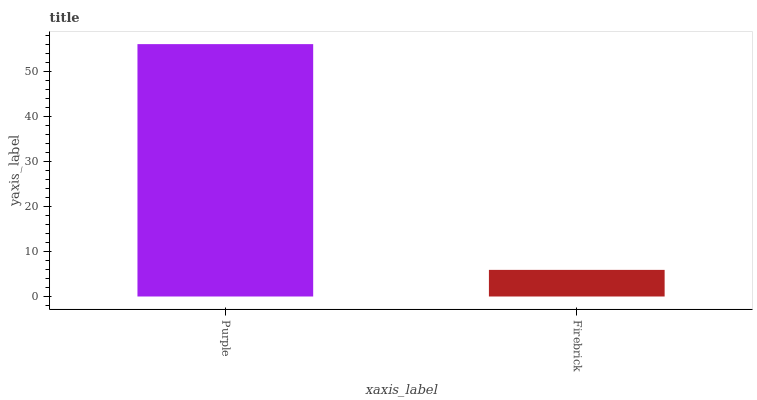Is Firebrick the minimum?
Answer yes or no. Yes. Is Purple the maximum?
Answer yes or no. Yes. Is Firebrick the maximum?
Answer yes or no. No. Is Purple greater than Firebrick?
Answer yes or no. Yes. Is Firebrick less than Purple?
Answer yes or no. Yes. Is Firebrick greater than Purple?
Answer yes or no. No. Is Purple less than Firebrick?
Answer yes or no. No. Is Purple the high median?
Answer yes or no. Yes. Is Firebrick the low median?
Answer yes or no. Yes. Is Firebrick the high median?
Answer yes or no. No. Is Purple the low median?
Answer yes or no. No. 